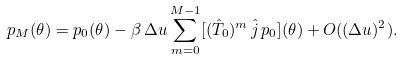<formula> <loc_0><loc_0><loc_500><loc_500>p _ { M } ( \theta ) = p _ { 0 } ( \theta ) - \beta \, \Delta u \sum _ { m = 0 } ^ { M - 1 } [ ( \hat { T } _ { 0 } ) ^ { m } \, \hat { j } \, p _ { 0 } ] ( \theta ) + O ( ( \Delta u ) ^ { 2 } ) .</formula> 